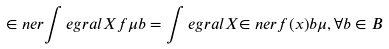Convert formula to latex. <formula><loc_0><loc_0><loc_500><loc_500>\in n e r { \int e g r a l { X } { f } { \mu } } { b } = \int e g r a l { X } { \in n e r { f ( x ) } { b } } { \mu } , \forall b \in B</formula> 